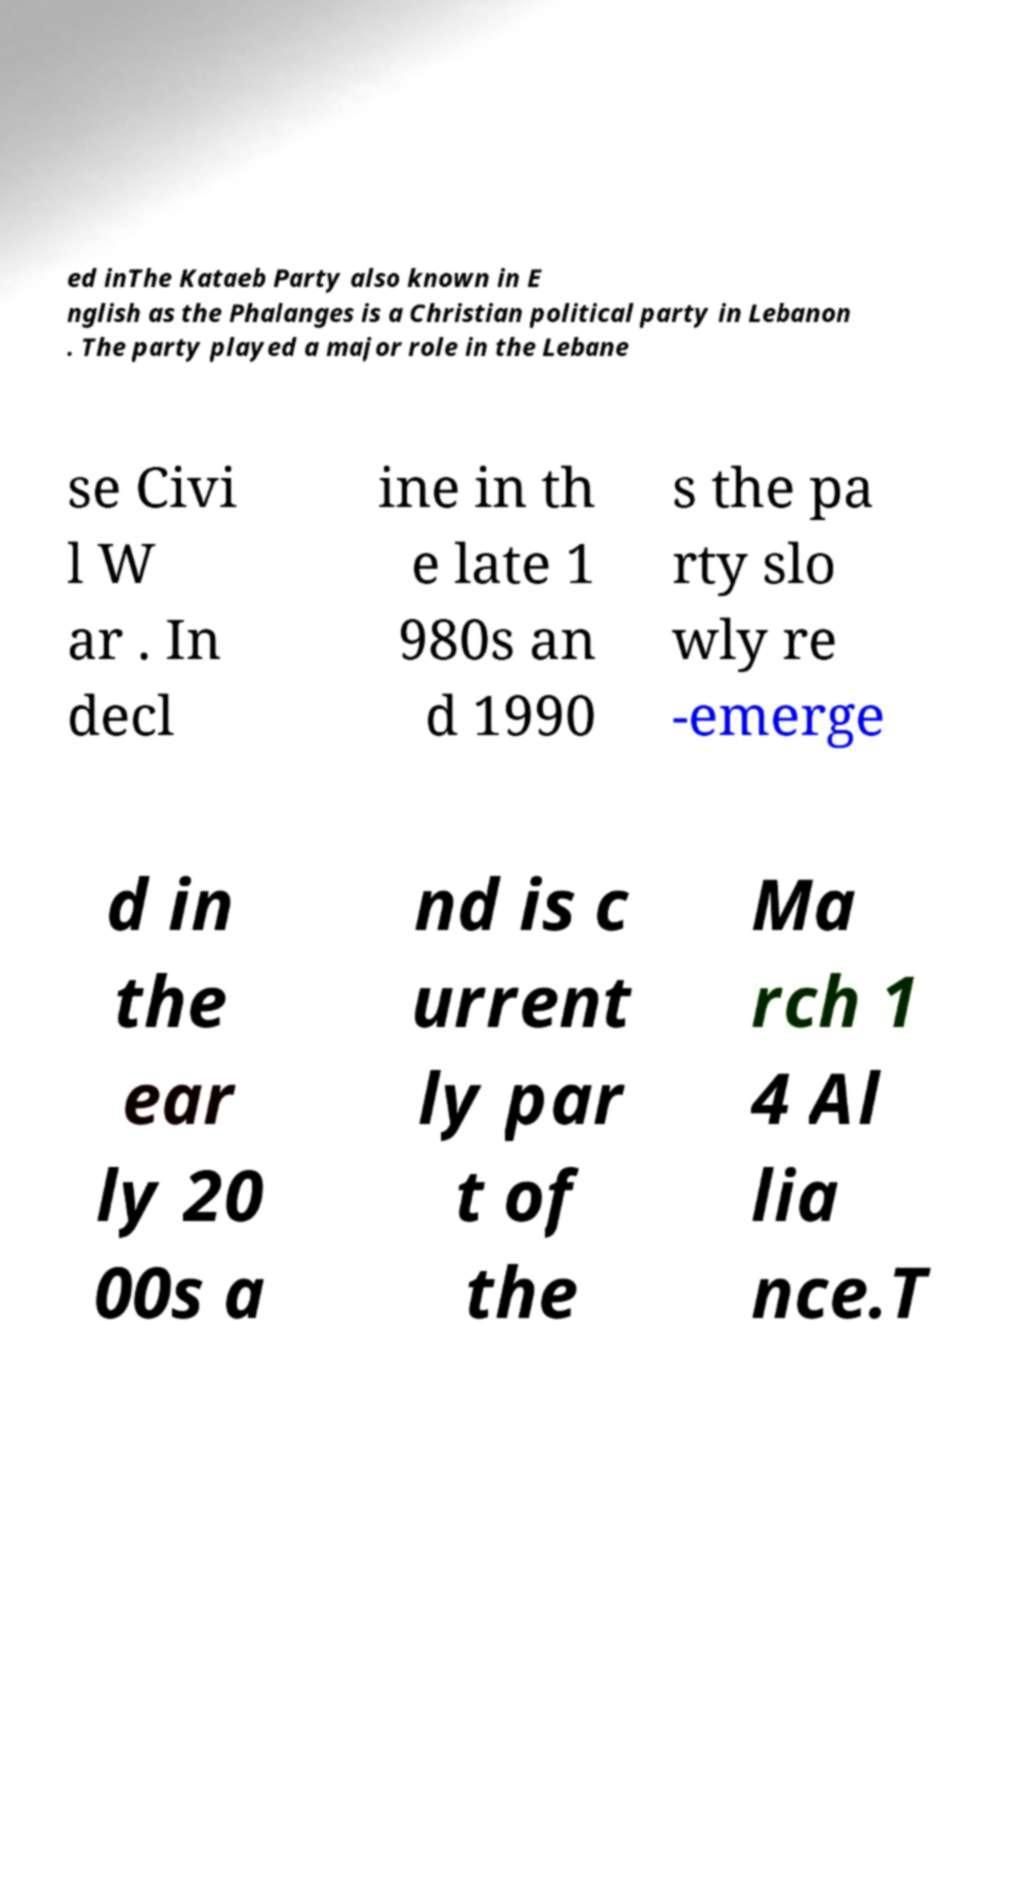I need the written content from this picture converted into text. Can you do that? ed inThe Kataeb Party also known in E nglish as the Phalanges is a Christian political party in Lebanon . The party played a major role in the Lebane se Civi l W ar . In decl ine in th e late 1 980s an d 1990 s the pa rty slo wly re -emerge d in the ear ly 20 00s a nd is c urrent ly par t of the Ma rch 1 4 Al lia nce.T 